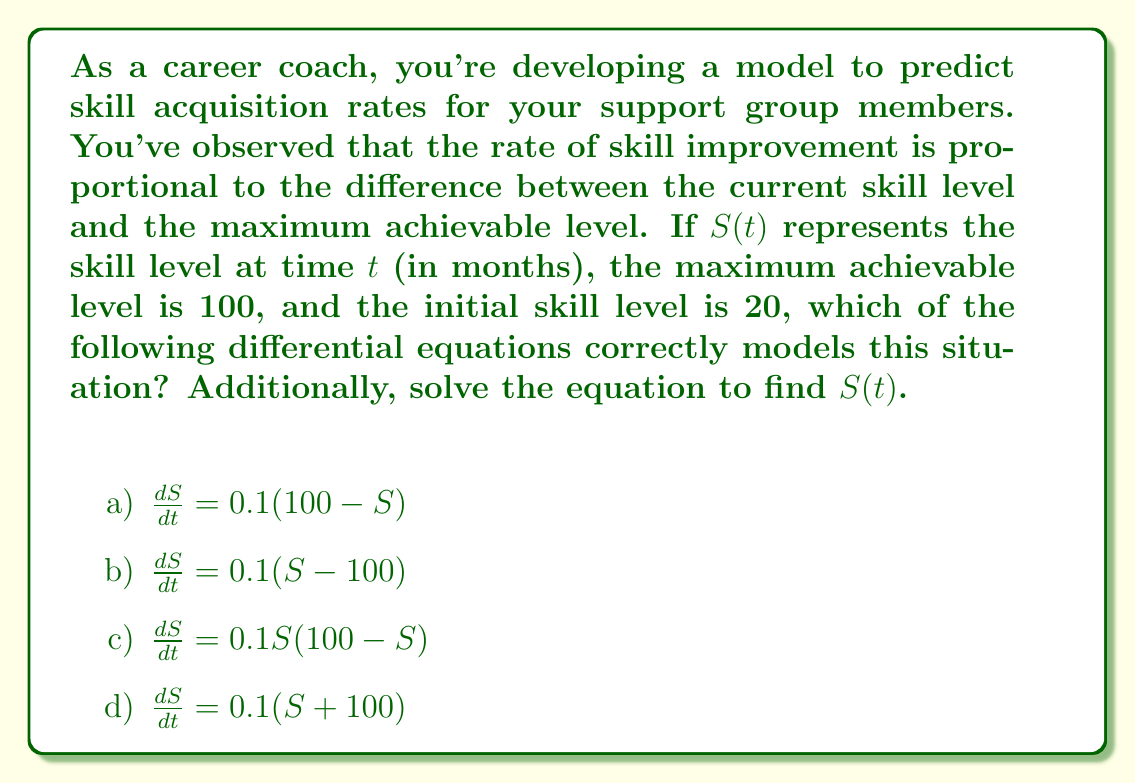Can you solve this math problem? Let's approach this step-by-step:

1) First, we need to identify the correct differential equation. The rate of change (improvement) should be proportional to the difference between the maximum level and the current level. This is best represented by option a: $\frac{dS}{dt} = 0.1(100 - S)$

2) Now, let's solve this first-order linear differential equation:

   $\frac{dS}{dt} = 0.1(100 - S)$

3) This is in the form $\frac{dS}{dt} + 0.1S = 10$, which is a linear first-order ODE.

4) The integrating factor is $e^{\int 0.1 dt} = e^{0.1t}$

5) Multiplying both sides by the integrating factor:

   $e^{0.1t}\frac{dS}{dt} + 0.1e^{0.1t}S = 10e^{0.1t}$

6) The left side is now the derivative of $e^{0.1t}S$:

   $\frac{d}{dt}(e^{0.1t}S) = 10e^{0.1t}$

7) Integrating both sides:

   $e^{0.1t}S = 100e^{0.1t} + C$

8) Solving for S:

   $S(t) = 100 + Ce^{-0.1t}$

9) Using the initial condition $S(0) = 20$:

   $20 = 100 + C$
   $C = -80$

10) Therefore, the final solution is:

    $S(t) = 100 - 80e^{-0.1t}$

This equation models the skill level $S$ at any time $t$, starting from 20 and approaching 100 as $t$ increases.
Answer: The correct differential equation is a) $\frac{dS}{dt} = 0.1(100 - S)$, and the solution is $S(t) = 100 - 80e^{-0.1t}$. 